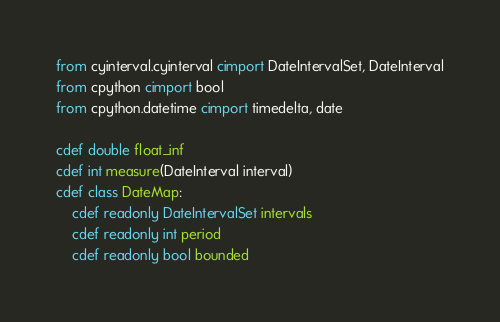Convert code to text. <code><loc_0><loc_0><loc_500><loc_500><_Cython_>from cyinterval.cyinterval cimport DateIntervalSet, DateInterval
from cpython cimport bool
from cpython.datetime cimport timedelta, date

cdef double float_inf
cdef int measure(DateInterval interval)
cdef class DateMap:
    cdef readonly DateIntervalSet intervals
    cdef readonly int period
    cdef readonly bool bounded</code> 